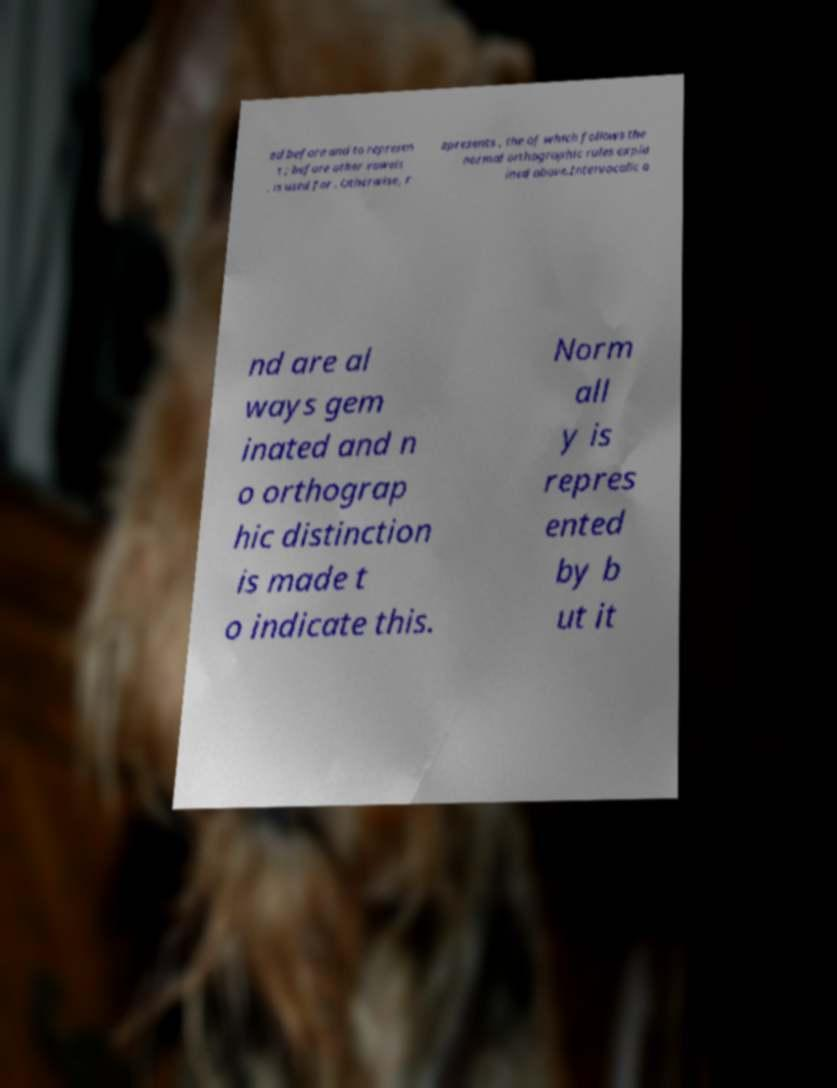Could you extract and type out the text from this image? ed before and to represen t ; before other vowels , is used for . Otherwise, r epresents , the of which follows the normal orthographic rules expla ined above.Intervocalic a nd are al ways gem inated and n o orthograp hic distinction is made t o indicate this. Norm all y is repres ented by b ut it 